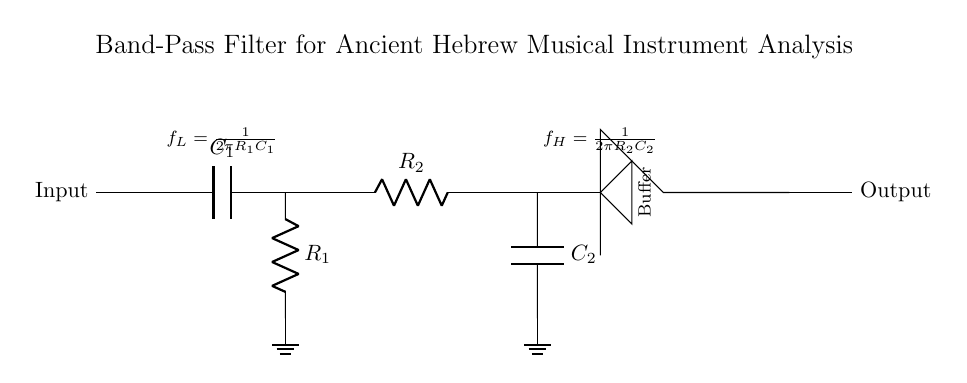What type of filter is represented in the circuit? The circuit is a band-pass filter, indicated by its structure that incorporates both high-pass and low-pass components.
Answer: band-pass filter What is the first component encountered after the input? The first component after the input is a capacitor, denoted as C1 in the diagram, which is the high-pass filter section.
Answer: capacitor What is the function of the buffer in this circuit? The buffer amplifies the output signal from the filter and isolates the output from the filter circuit, preventing loading effects that could alter the signal.
Answer: amplify What are the equations indicating the low and high cutoff frequencies? The low cutoff frequency (fL) is given by the equation fL = 1/(2πR1C1) and the high cutoff frequency (fH) is given by the equation fH = 1/(2πR2C2). Both equations are shown as annotations on the circuit diagram.
Answer: fL = 1/(2πR1C1), fH = 1/(2πR2C2) Which component is responsible for blocking low frequencies? The capacitor C1 in the high-pass filter section is responsible for blocking low frequencies, allowing only higher frequencies to pass through the circuit.
Answer: C1 How many resistors are present in this band-pass filter? There are two resistors in the circuit, indicated as R1 for the high-pass filter and R2 for the low-pass filter.
Answer: two What configuration does the filter use to allow a specific range of frequencies? The filter combines a high-pass and a low-pass filter in series, allowing only frequencies between the low and high cutoff frequencies to pass through, creating a band-pass effect.
Answer: series configuration 